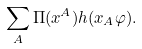<formula> <loc_0><loc_0><loc_500><loc_500>\sum _ { A } \Pi ( x ^ { A } ) h ( x _ { A } \varphi ) .</formula> 